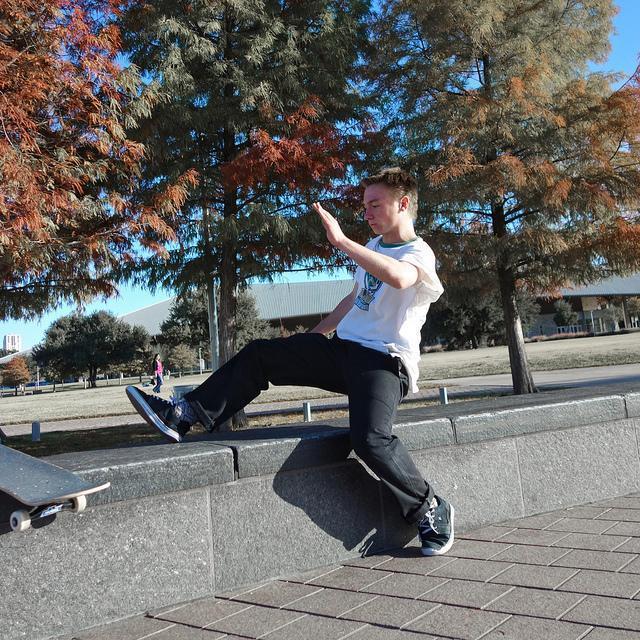How many orange cats are there in the image?
Give a very brief answer. 0. 